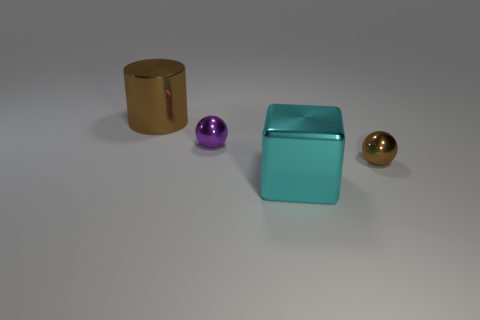Add 3 small blue rubber cylinders. How many objects exist? 7 Subtract 0 gray cylinders. How many objects are left? 4 Subtract all cylinders. How many objects are left? 3 Subtract all small purple spheres. Subtract all small red rubber balls. How many objects are left? 3 Add 2 metal blocks. How many metal blocks are left? 3 Add 1 metal spheres. How many metal spheres exist? 3 